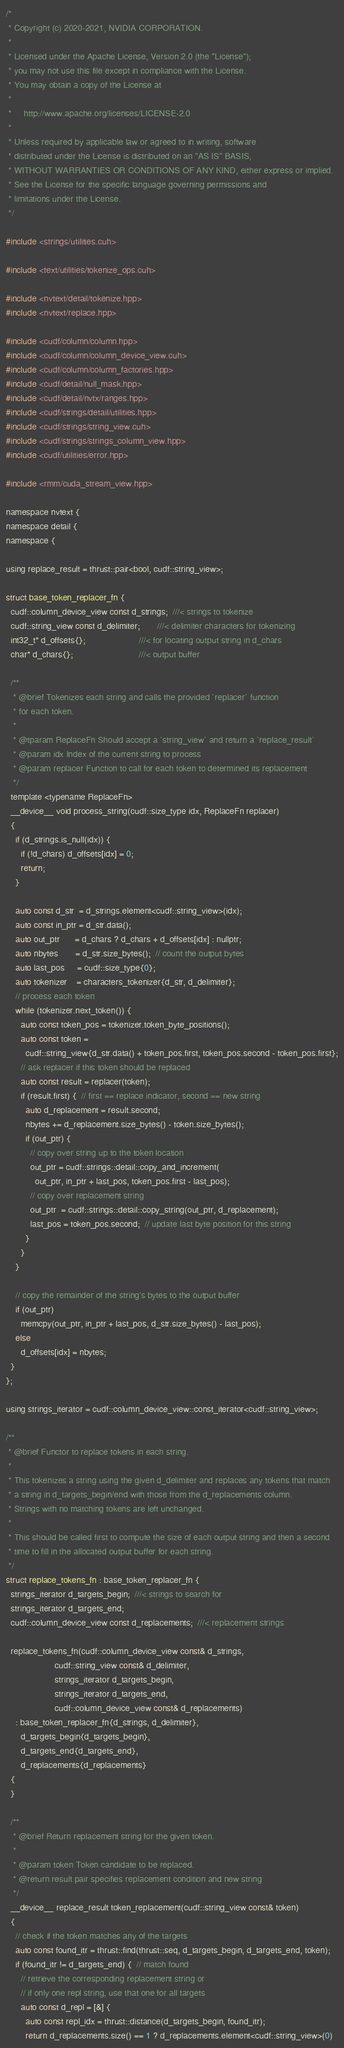Convert code to text. <code><loc_0><loc_0><loc_500><loc_500><_Cuda_>/*
 * Copyright (c) 2020-2021, NVIDIA CORPORATION.
 *
 * Licensed under the Apache License, Version 2.0 (the "License");
 * you may not use this file except in compliance with the License.
 * You may obtain a copy of the License at
 *
 *     http://www.apache.org/licenses/LICENSE-2.0
 *
 * Unless required by applicable law or agreed to in writing, software
 * distributed under the License is distributed on an "AS IS" BASIS,
 * WITHOUT WARRANTIES OR CONDITIONS OF ANY KIND, either express or implied.
 * See the License for the specific language governing permissions and
 * limitations under the License.
 */

#include <strings/utilities.cuh>

#include <text/utilities/tokenize_ops.cuh>

#include <nvtext/detail/tokenize.hpp>
#include <nvtext/replace.hpp>

#include <cudf/column/column.hpp>
#include <cudf/column/column_device_view.cuh>
#include <cudf/column/column_factories.hpp>
#include <cudf/detail/null_mask.hpp>
#include <cudf/detail/nvtx/ranges.hpp>
#include <cudf/strings/detail/utilities.hpp>
#include <cudf/strings/string_view.cuh>
#include <cudf/strings/strings_column_view.hpp>
#include <cudf/utilities/error.hpp>

#include <rmm/cuda_stream_view.hpp>

namespace nvtext {
namespace detail {
namespace {

using replace_result = thrust::pair<bool, cudf::string_view>;

struct base_token_replacer_fn {
  cudf::column_device_view const d_strings;  ///< strings to tokenize
  cudf::string_view const d_delimiter;       ///< delimiter characters for tokenizing
  int32_t* d_offsets{};                      ///< for locating output string in d_chars
  char* d_chars{};                           ///< output buffer

  /**
   * @brief Tokenizes each string and calls the provided `replacer` function
   * for each token.
   *
   * @tparam ReplaceFn Should accept a `string_view` and return a `replace_result`
   * @param idx Index of the current string to process
   * @param replacer Function to call for each token to determined its replacement
   */
  template <typename ReplaceFn>
  __device__ void process_string(cudf::size_type idx, ReplaceFn replacer)
  {
    if (d_strings.is_null(idx)) {
      if (!d_chars) d_offsets[idx] = 0;
      return;
    }

    auto const d_str  = d_strings.element<cudf::string_view>(idx);
    auto const in_ptr = d_str.data();
    auto out_ptr      = d_chars ? d_chars + d_offsets[idx] : nullptr;
    auto nbytes       = d_str.size_bytes();  // count the output bytes
    auto last_pos     = cudf::size_type{0};
    auto tokenizer    = characters_tokenizer{d_str, d_delimiter};
    // process each token
    while (tokenizer.next_token()) {
      auto const token_pos = tokenizer.token_byte_positions();
      auto const token =
        cudf::string_view{d_str.data() + token_pos.first, token_pos.second - token_pos.first};
      // ask replacer if this token should be replaced
      auto const result = replacer(token);
      if (result.first) {  // first == replace indicator, second == new string
        auto d_replacement = result.second;
        nbytes += d_replacement.size_bytes() - token.size_bytes();
        if (out_ptr) {
          // copy over string up to the token location
          out_ptr = cudf::strings::detail::copy_and_increment(
            out_ptr, in_ptr + last_pos, token_pos.first - last_pos);
          // copy over replacement string
          out_ptr  = cudf::strings::detail::copy_string(out_ptr, d_replacement);
          last_pos = token_pos.second;  // update last byte position for this string
        }
      }
    }

    // copy the remainder of the string's bytes to the output buffer
    if (out_ptr)
      memcpy(out_ptr, in_ptr + last_pos, d_str.size_bytes() - last_pos);
    else
      d_offsets[idx] = nbytes;
  }
};

using strings_iterator = cudf::column_device_view::const_iterator<cudf::string_view>;

/**
 * @brief Functor to replace tokens in each string.
 *
 * This tokenizes a string using the given d_delimiter and replaces any tokens that match
 * a string in d_targets_begin/end with those from the d_replacements column.
 * Strings with no matching tokens are left unchanged.
 *
 * This should be called first to compute the size of each output string and then a second
 * time to fill in the allocated output buffer for each string.
 */
struct replace_tokens_fn : base_token_replacer_fn {
  strings_iterator d_targets_begin;  ///< strings to search for
  strings_iterator d_targets_end;
  cudf::column_device_view const d_replacements;  ///< replacement strings

  replace_tokens_fn(cudf::column_device_view const& d_strings,
                    cudf::string_view const& d_delimiter,
                    strings_iterator d_targets_begin,
                    strings_iterator d_targets_end,
                    cudf::column_device_view const& d_replacements)
    : base_token_replacer_fn{d_strings, d_delimiter},
      d_targets_begin{d_targets_begin},
      d_targets_end{d_targets_end},
      d_replacements{d_replacements}
  {
  }

  /**
   * @brief Return replacement string for the given token.
   *
   * @param token Token candidate to be replaced.
   * @return result pair specifies replacement condition and new string
   */
  __device__ replace_result token_replacement(cudf::string_view const& token)
  {
    // check if the token matches any of the targets
    auto const found_itr = thrust::find(thrust::seq, d_targets_begin, d_targets_end, token);
    if (found_itr != d_targets_end) {  // match found
      // retrieve the corresponding replacement string or
      // if only one repl string, use that one for all targets
      auto const d_repl = [&] {
        auto const repl_idx = thrust::distance(d_targets_begin, found_itr);
        return d_replacements.size() == 1 ? d_replacements.element<cudf::string_view>(0)</code> 